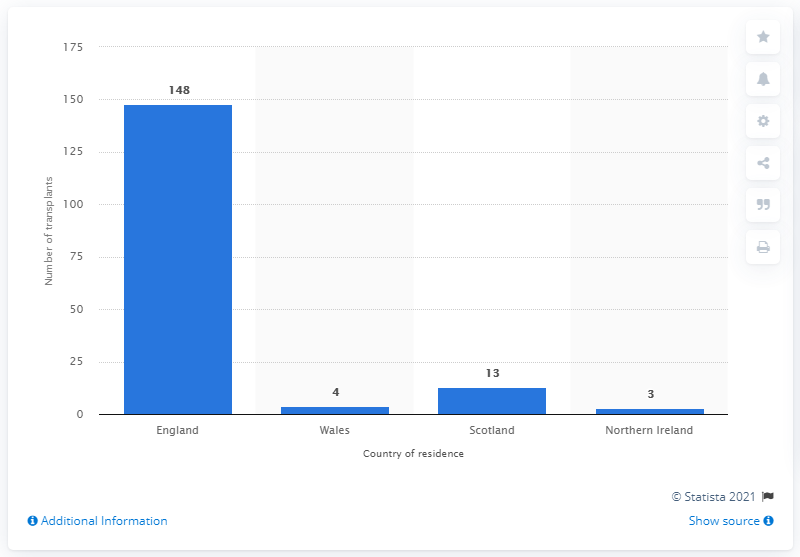Outline some significant characteristics in this image. In 2019/18, the country with the most heart transplants was Wales. Scotland performed the most heart transplants in 2019 and 2018, making it the country with the highest number of heart transplants. In 2019/2018, 148 heart transplants were performed in England. 